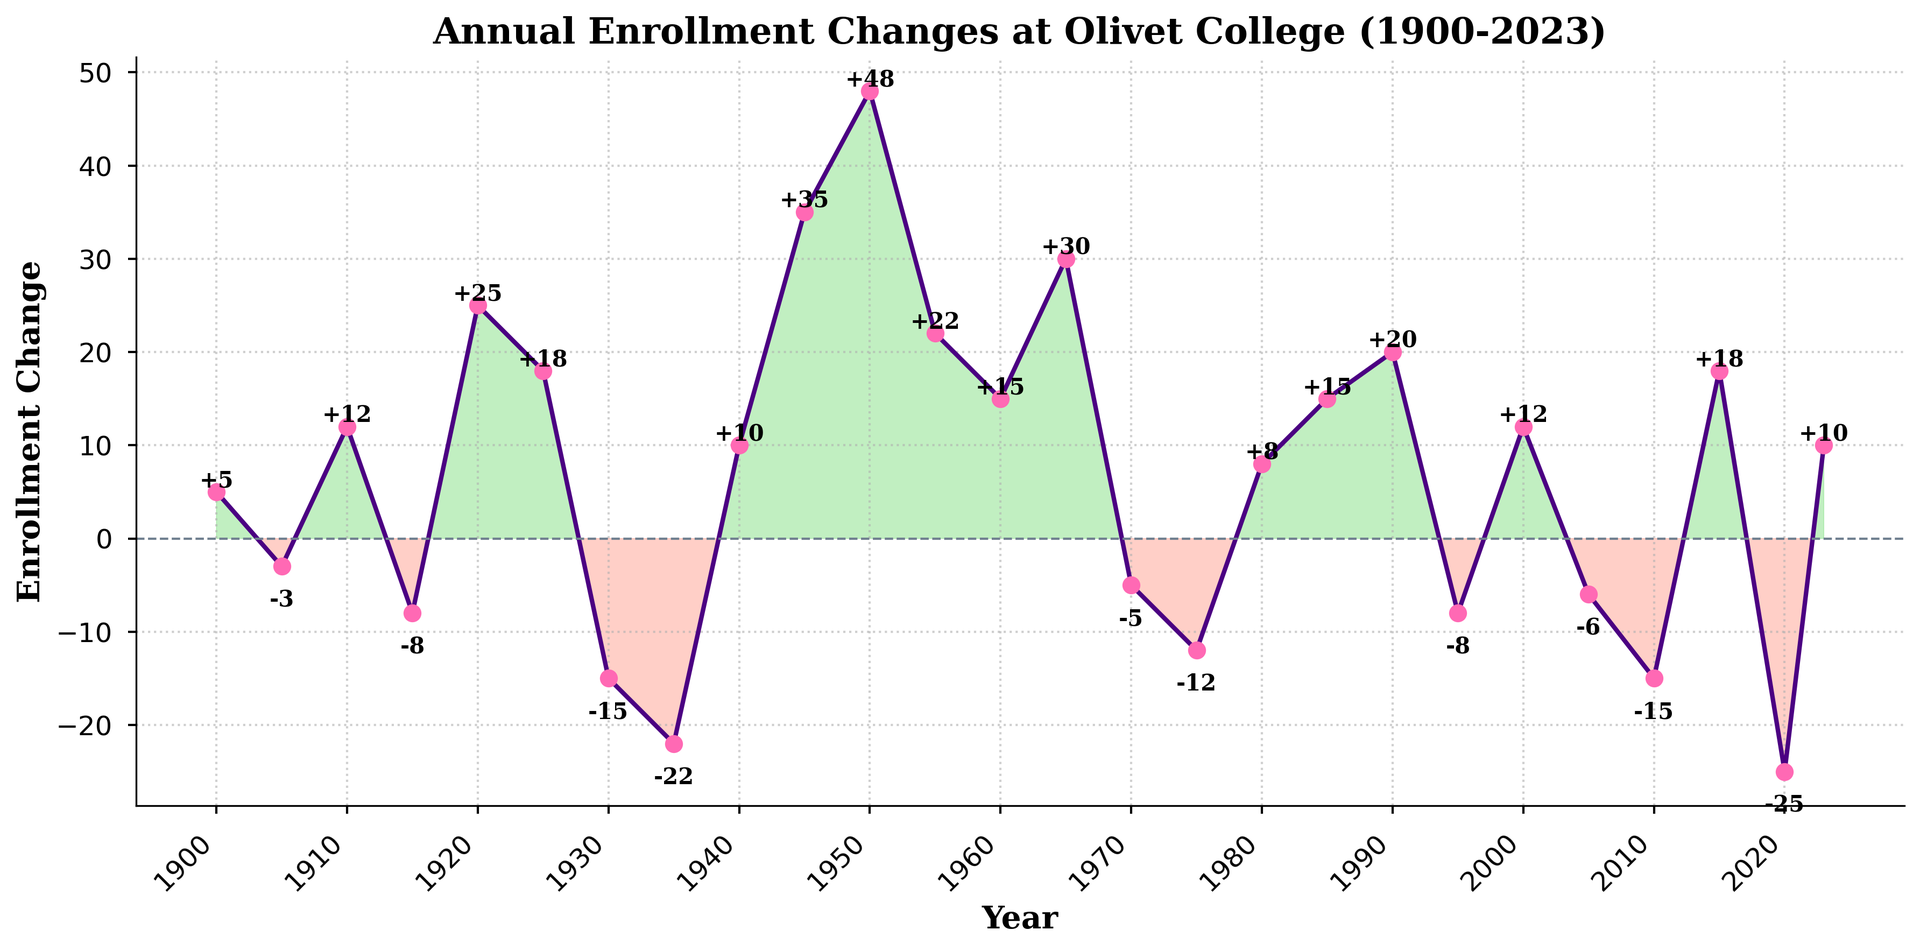In which year did Olivet College see the highest annual enrollment increase? The highest point on the graph is at the year 1950, reaching an enrollment change of 48.
Answer: 1950 What was the net enrollment change at Olivet College for the period 1910 to 1930? The enrollment changes for these years are: 1910 (12), 1915 (-8), 1920 (25), 1925 (18), 1930 (-15). Summing them up: 12 + (-8) + 25 + 18 + (-15) = 32.
Answer: 32 Identify two consecutive periods where enrollment increased dramatically, then declined. The first instance occurs between 1910 and 1915 (from +12 to -8), and the second instance occurs between 1925 and 1930 (from +18 to -15).
Answer: 1910-1915, 1925-1930 What color represents periods of enrollment decline in the graph? Periods of enrollment decline are shaded in red on the graph.
Answer: Red During which decade did Olivet College experience a major upward trend in enrollment change, and what was the cumulative change for that decade? The upward trend is observed from 1940 to 1950, with changes: 1940 (10), 1945 (35), 1950 (48). Summing these up: 10 + 35 + 48 = 93.
Answer: 1940s, 93 Did Olivet College experience more annual declines or increases in enrollment from 1900 to 2023? Counting the points where there's an increase versus a decline, there are 12 years of increases (positive values) and 10 years of declines (negative values).
Answer: More increases How does the enrollment change in 1980 compare to 1985? In 1980, the enrollment change is +8, and in 1985, it is +15.
Answer: Increased from 8 to 15 Which year marked the lowest annual enrollment change at Olivet College? The lowest point on the graph is at the year 1935, with an enrollment change of -22.
Answer: 1935 What was the cumulative enrollment change from 2020 to 2023? The changes for these years are: 2020 (-25) and 2023 (10). Summing them up: -25 + 10 = -15.
Answer: -15 Does the graph indicate any visual trend during wartime periods such as the 1940s around World War II? Yes, during the 1940s there is a noticeable positive trend, particularly in 1945 and 1950, indicating recovery or growth post-World War II.
Answer: Positive trend 